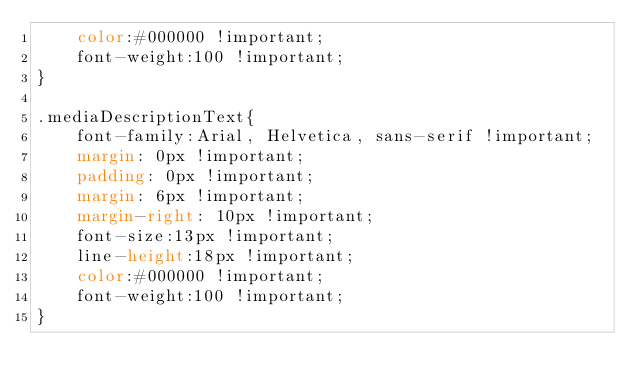<code> <loc_0><loc_0><loc_500><loc_500><_CSS_>	color:#000000 !important;
	font-weight:100 !important;
}

.mediaDescriptionText{
	font-family:Arial, Helvetica, sans-serif !important;
	margin: 0px !important;
	padding: 0px !important;
	margin: 6px !important;
	margin-right: 10px !important;
	font-size:13px !important;
	line-height:18px !important;
	color:#000000 !important;
	font-weight:100 !important;
}
</code> 